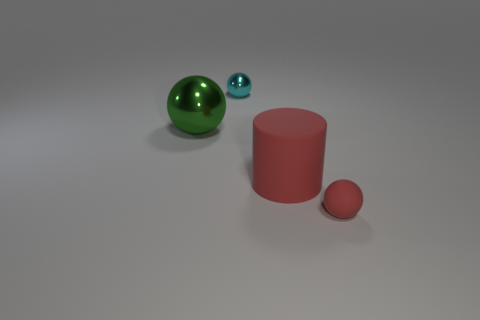What number of tiny cyan metal objects are to the right of the small shiny thing?
Offer a terse response. 0. What color is the small ball that is made of the same material as the green object?
Offer a terse response. Cyan. Is the big red thing the same shape as the small cyan metallic object?
Provide a short and direct response. No. What number of small spheres are to the right of the large matte object and behind the green sphere?
Your answer should be compact. 0. How many shiny things are gray cubes or large green spheres?
Offer a terse response. 1. There is a thing that is on the left side of the thing that is behind the green shiny sphere; what size is it?
Your response must be concise. Large. What material is the small sphere that is the same color as the rubber cylinder?
Offer a terse response. Rubber. There is a small sphere that is behind the ball that is in front of the large green shiny thing; are there any large rubber things on the right side of it?
Provide a succinct answer. Yes. Is the material of the ball that is in front of the cylinder the same as the thing on the left side of the cyan ball?
Provide a short and direct response. No. What number of things are either big red rubber cylinders or metal things behind the large green ball?
Provide a short and direct response. 2. 